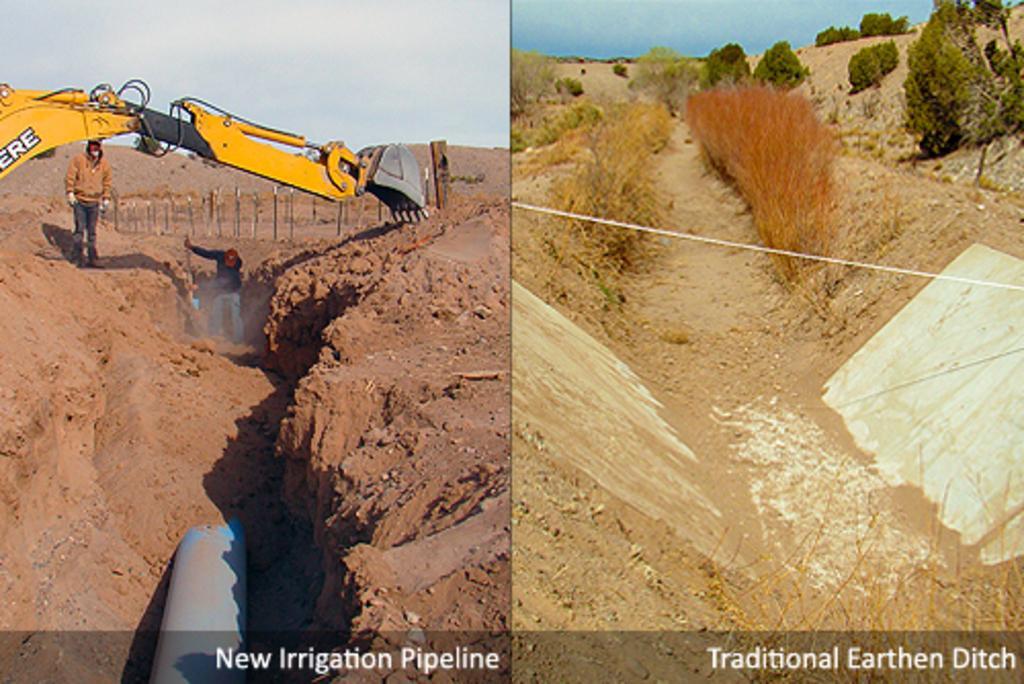Could you give a brief overview of what you see in this image? In the image on the left side we can see the sky,clouds,excavator,pipe,soil and two persons were standing and holding some objects. On the right side of the image,we can see the sky,clouds,trees,plants and grass. In the bottom of the image,we can see watermarks. 